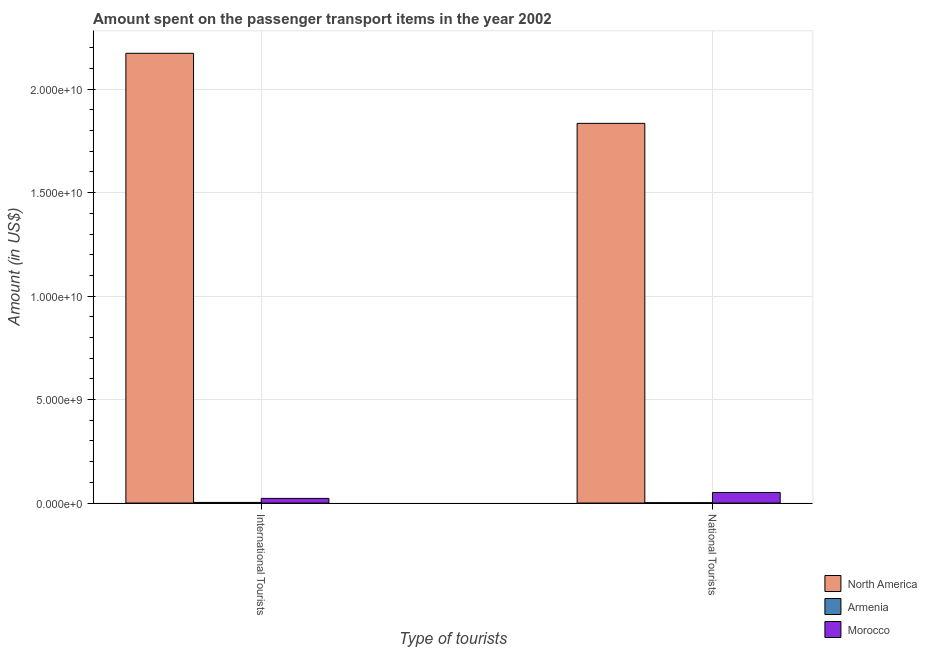How many different coloured bars are there?
Ensure brevity in your answer.  3. How many groups of bars are there?
Offer a terse response. 2. Are the number of bars per tick equal to the number of legend labels?
Provide a short and direct response. Yes. Are the number of bars on each tick of the X-axis equal?
Your answer should be very brief. Yes. How many bars are there on the 1st tick from the left?
Offer a very short reply. 3. What is the label of the 1st group of bars from the left?
Provide a short and direct response. International Tourists. What is the amount spent on transport items of national tourists in North America?
Provide a short and direct response. 1.83e+1. Across all countries, what is the maximum amount spent on transport items of international tourists?
Your answer should be compact. 2.17e+1. Across all countries, what is the minimum amount spent on transport items of international tourists?
Make the answer very short. 3.10e+07. In which country was the amount spent on transport items of national tourists minimum?
Give a very brief answer. Armenia. What is the total amount spent on transport items of national tourists in the graph?
Provide a succinct answer. 1.89e+1. What is the difference between the amount spent on transport items of national tourists in North America and that in Morocco?
Keep it short and to the point. 1.78e+1. What is the difference between the amount spent on transport items of national tourists in Morocco and the amount spent on transport items of international tourists in North America?
Provide a succinct answer. -2.12e+1. What is the average amount spent on transport items of national tourists per country?
Make the answer very short. 6.29e+09. What is the difference between the amount spent on transport items of international tourists and amount spent on transport items of national tourists in Armenia?
Give a very brief answer. 1.30e+07. What is the ratio of the amount spent on transport items of national tourists in Armenia to that in North America?
Your answer should be very brief. 0. Is the amount spent on transport items of national tourists in Armenia less than that in North America?
Your response must be concise. Yes. What does the 1st bar from the right in National Tourists represents?
Offer a very short reply. Morocco. Are all the bars in the graph horizontal?
Your answer should be compact. No. Are the values on the major ticks of Y-axis written in scientific E-notation?
Ensure brevity in your answer.  Yes. Does the graph contain any zero values?
Ensure brevity in your answer.  No. What is the title of the graph?
Make the answer very short. Amount spent on the passenger transport items in the year 2002. What is the label or title of the X-axis?
Provide a short and direct response. Type of tourists. What is the label or title of the Y-axis?
Offer a terse response. Amount (in US$). What is the Amount (in US$) in North America in International Tourists?
Offer a very short reply. 2.17e+1. What is the Amount (in US$) in Armenia in International Tourists?
Provide a succinct answer. 3.10e+07. What is the Amount (in US$) in Morocco in International Tourists?
Make the answer very short. 2.25e+08. What is the Amount (in US$) of North America in National Tourists?
Offer a very short reply. 1.83e+1. What is the Amount (in US$) in Armenia in National Tourists?
Offer a very short reply. 1.80e+07. What is the Amount (in US$) in Morocco in National Tourists?
Your answer should be very brief. 5.11e+08. Across all Type of tourists, what is the maximum Amount (in US$) in North America?
Provide a short and direct response. 2.17e+1. Across all Type of tourists, what is the maximum Amount (in US$) in Armenia?
Make the answer very short. 3.10e+07. Across all Type of tourists, what is the maximum Amount (in US$) in Morocco?
Your response must be concise. 5.11e+08. Across all Type of tourists, what is the minimum Amount (in US$) of North America?
Provide a succinct answer. 1.83e+1. Across all Type of tourists, what is the minimum Amount (in US$) in Armenia?
Provide a succinct answer. 1.80e+07. Across all Type of tourists, what is the minimum Amount (in US$) in Morocco?
Keep it short and to the point. 2.25e+08. What is the total Amount (in US$) in North America in the graph?
Provide a succinct answer. 4.01e+1. What is the total Amount (in US$) of Armenia in the graph?
Ensure brevity in your answer.  4.90e+07. What is the total Amount (in US$) in Morocco in the graph?
Provide a succinct answer. 7.36e+08. What is the difference between the Amount (in US$) of North America in International Tourists and that in National Tourists?
Provide a short and direct response. 3.39e+09. What is the difference between the Amount (in US$) in Armenia in International Tourists and that in National Tourists?
Your response must be concise. 1.30e+07. What is the difference between the Amount (in US$) of Morocco in International Tourists and that in National Tourists?
Make the answer very short. -2.86e+08. What is the difference between the Amount (in US$) of North America in International Tourists and the Amount (in US$) of Armenia in National Tourists?
Offer a terse response. 2.17e+1. What is the difference between the Amount (in US$) of North America in International Tourists and the Amount (in US$) of Morocco in National Tourists?
Offer a terse response. 2.12e+1. What is the difference between the Amount (in US$) in Armenia in International Tourists and the Amount (in US$) in Morocco in National Tourists?
Your answer should be very brief. -4.80e+08. What is the average Amount (in US$) of North America per Type of tourists?
Give a very brief answer. 2.00e+1. What is the average Amount (in US$) of Armenia per Type of tourists?
Your answer should be very brief. 2.45e+07. What is the average Amount (in US$) in Morocco per Type of tourists?
Your answer should be very brief. 3.68e+08. What is the difference between the Amount (in US$) in North America and Amount (in US$) in Armenia in International Tourists?
Offer a terse response. 2.17e+1. What is the difference between the Amount (in US$) of North America and Amount (in US$) of Morocco in International Tourists?
Provide a short and direct response. 2.15e+1. What is the difference between the Amount (in US$) in Armenia and Amount (in US$) in Morocco in International Tourists?
Offer a very short reply. -1.94e+08. What is the difference between the Amount (in US$) in North America and Amount (in US$) in Armenia in National Tourists?
Keep it short and to the point. 1.83e+1. What is the difference between the Amount (in US$) in North America and Amount (in US$) in Morocco in National Tourists?
Provide a succinct answer. 1.78e+1. What is the difference between the Amount (in US$) in Armenia and Amount (in US$) in Morocco in National Tourists?
Offer a very short reply. -4.93e+08. What is the ratio of the Amount (in US$) in North America in International Tourists to that in National Tourists?
Provide a short and direct response. 1.18. What is the ratio of the Amount (in US$) of Armenia in International Tourists to that in National Tourists?
Ensure brevity in your answer.  1.72. What is the ratio of the Amount (in US$) in Morocco in International Tourists to that in National Tourists?
Your response must be concise. 0.44. What is the difference between the highest and the second highest Amount (in US$) of North America?
Your answer should be compact. 3.39e+09. What is the difference between the highest and the second highest Amount (in US$) in Armenia?
Your answer should be very brief. 1.30e+07. What is the difference between the highest and the second highest Amount (in US$) of Morocco?
Ensure brevity in your answer.  2.86e+08. What is the difference between the highest and the lowest Amount (in US$) of North America?
Your answer should be very brief. 3.39e+09. What is the difference between the highest and the lowest Amount (in US$) of Armenia?
Provide a succinct answer. 1.30e+07. What is the difference between the highest and the lowest Amount (in US$) of Morocco?
Ensure brevity in your answer.  2.86e+08. 